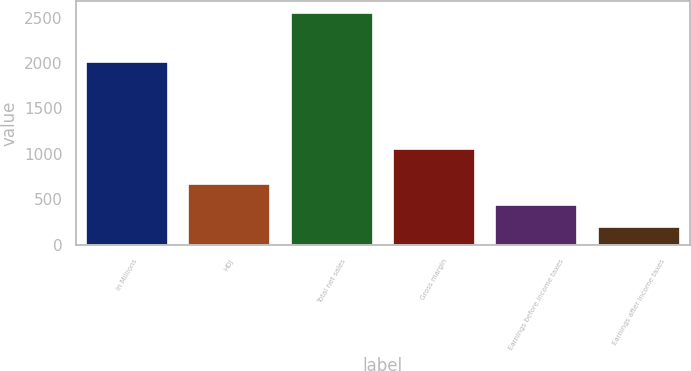<chart> <loc_0><loc_0><loc_500><loc_500><bar_chart><fcel>In Millions<fcel>HDJ<fcel>Total net sales<fcel>Gross margin<fcel>Earnings before income taxes<fcel>Earnings after income taxes<nl><fcel>2013<fcel>671.82<fcel>2552.7<fcel>1057.3<fcel>436.71<fcel>201.6<nl></chart> 